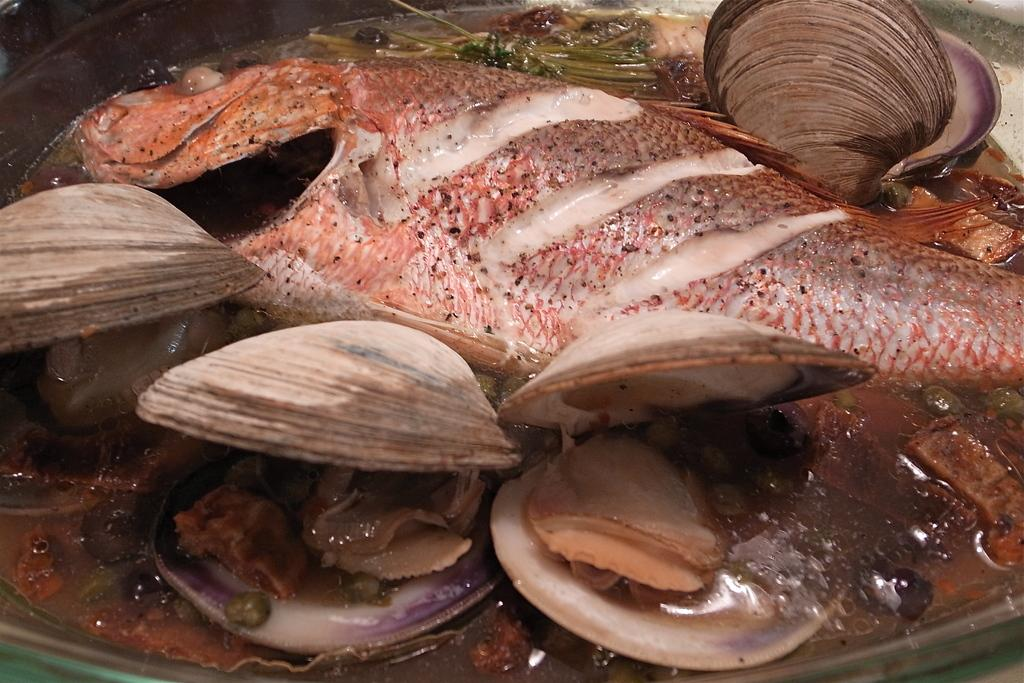What is the focus of the image? The image is zoomed in on a platter. What is on the platter? The platter contains food items, including oysters and a fish. Can you describe the food items on the platter? The platter contains oysters and a fish. What type of riddle is the fish trying to solve on the platter? There is no indication in the image that the fish is trying to solve a riddle, as it is a food item and not an animate being. 